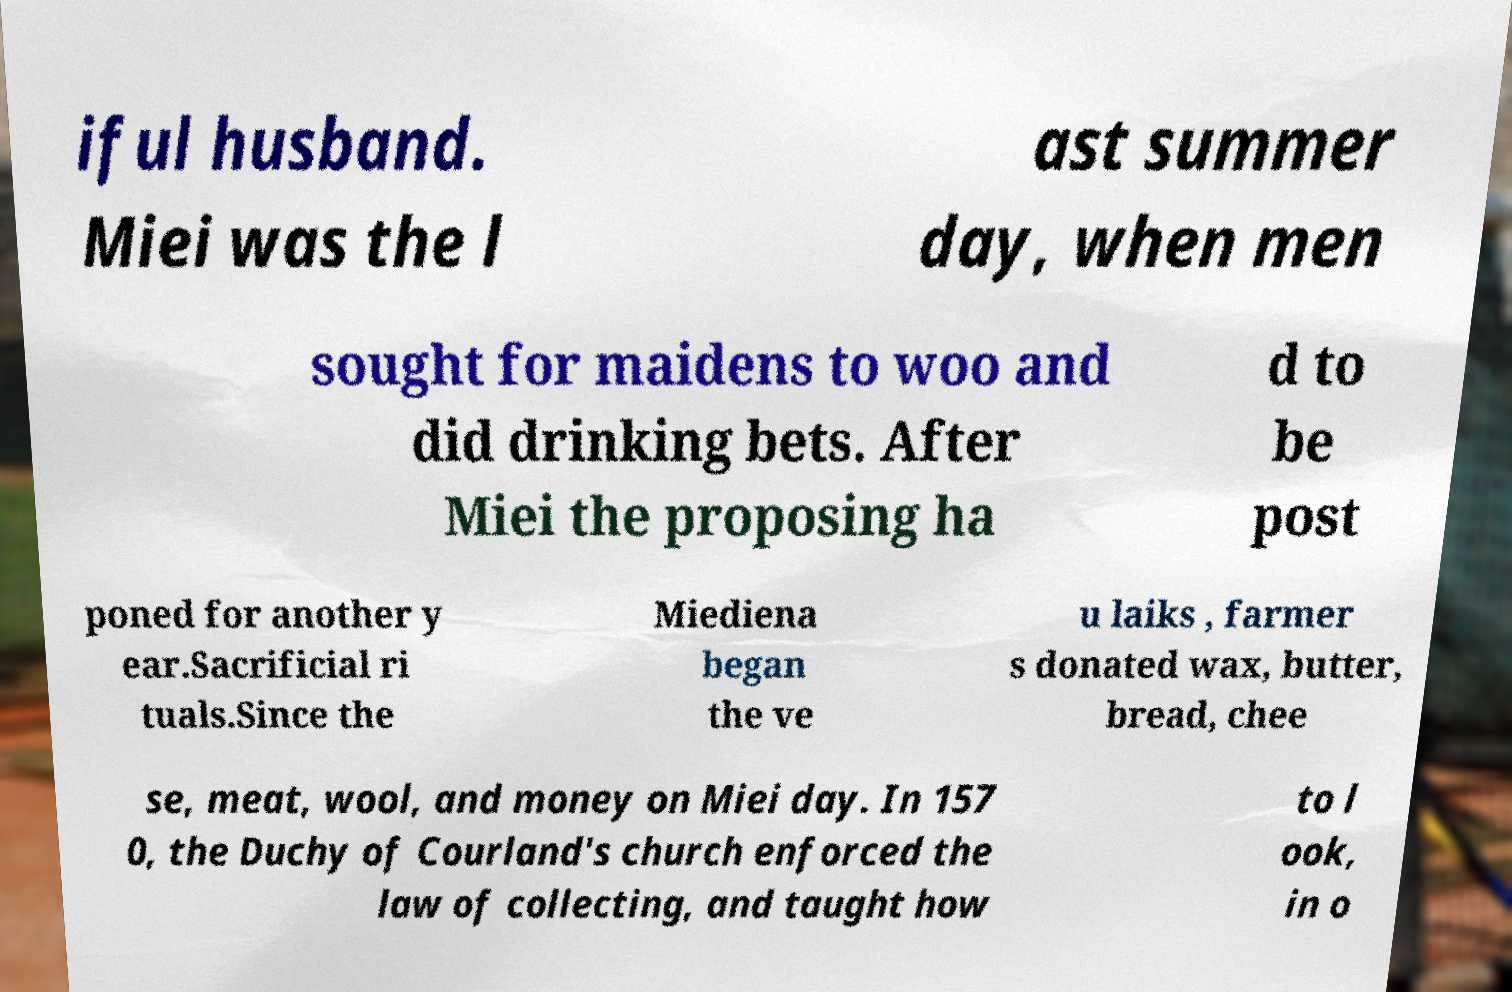For documentation purposes, I need the text within this image transcribed. Could you provide that? iful husband. Miei was the l ast summer day, when men sought for maidens to woo and did drinking bets. After Miei the proposing ha d to be post poned for another y ear.Sacrificial ri tuals.Since the Miediena began the ve u laiks , farmer s donated wax, butter, bread, chee se, meat, wool, and money on Miei day. In 157 0, the Duchy of Courland's church enforced the law of collecting, and taught how to l ook, in o 